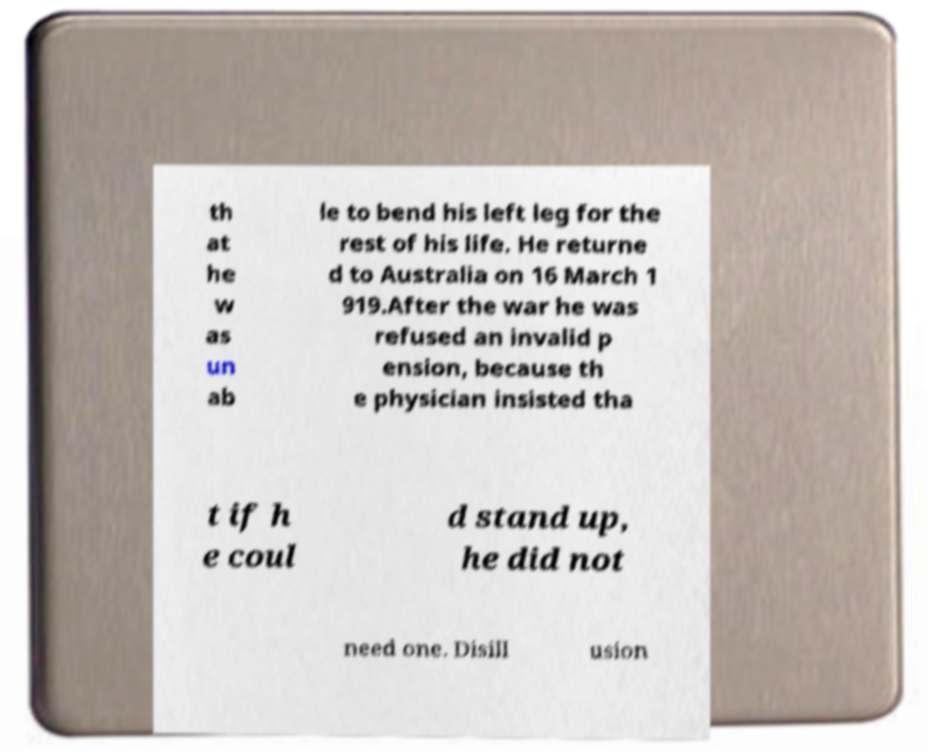Can you accurately transcribe the text from the provided image for me? th at he w as un ab le to bend his left leg for the rest of his life. He returne d to Australia on 16 March 1 919.After the war he was refused an invalid p ension, because th e physician insisted tha t if h e coul d stand up, he did not need one. Disill usion 